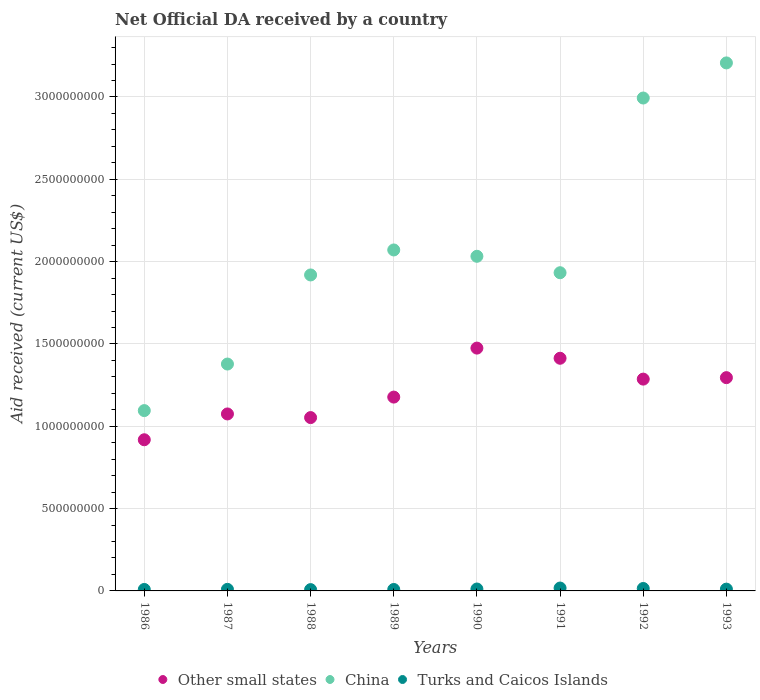What is the net official development assistance aid received in Other small states in 1986?
Your answer should be compact. 9.18e+08. Across all years, what is the maximum net official development assistance aid received in Other small states?
Provide a succinct answer. 1.47e+09. Across all years, what is the minimum net official development assistance aid received in Other small states?
Your answer should be compact. 9.18e+08. In which year was the net official development assistance aid received in Turks and Caicos Islands maximum?
Keep it short and to the point. 1991. In which year was the net official development assistance aid received in Turks and Caicos Islands minimum?
Offer a very short reply. 1988. What is the total net official development assistance aid received in Other small states in the graph?
Your answer should be very brief. 9.69e+09. What is the difference between the net official development assistance aid received in Turks and Caicos Islands in 1990 and that in 1992?
Keep it short and to the point. -3.20e+06. What is the difference between the net official development assistance aid received in China in 1991 and the net official development assistance aid received in Turks and Caicos Islands in 1992?
Provide a succinct answer. 1.92e+09. What is the average net official development assistance aid received in Other small states per year?
Your answer should be compact. 1.21e+09. In the year 1992, what is the difference between the net official development assistance aid received in China and net official development assistance aid received in Turks and Caicos Islands?
Your answer should be very brief. 2.98e+09. What is the ratio of the net official development assistance aid received in Turks and Caicos Islands in 1988 to that in 1989?
Your response must be concise. 0.9. Is the difference between the net official development assistance aid received in China in 1986 and 1987 greater than the difference between the net official development assistance aid received in Turks and Caicos Islands in 1986 and 1987?
Your answer should be very brief. No. What is the difference between the highest and the second highest net official development assistance aid received in China?
Your answer should be very brief. 2.13e+08. What is the difference between the highest and the lowest net official development assistance aid received in Other small states?
Your answer should be compact. 5.57e+08. Is it the case that in every year, the sum of the net official development assistance aid received in China and net official development assistance aid received in Other small states  is greater than the net official development assistance aid received in Turks and Caicos Islands?
Your answer should be very brief. Yes. Does the net official development assistance aid received in Turks and Caicos Islands monotonically increase over the years?
Your answer should be compact. No. Is the net official development assistance aid received in Other small states strictly greater than the net official development assistance aid received in China over the years?
Ensure brevity in your answer.  No. How many dotlines are there?
Offer a very short reply. 3. How many years are there in the graph?
Your answer should be compact. 8. What is the difference between two consecutive major ticks on the Y-axis?
Offer a terse response. 5.00e+08. Are the values on the major ticks of Y-axis written in scientific E-notation?
Offer a terse response. No. Does the graph contain grids?
Keep it short and to the point. Yes. What is the title of the graph?
Your answer should be very brief. Net Official DA received by a country. What is the label or title of the X-axis?
Keep it short and to the point. Years. What is the label or title of the Y-axis?
Keep it short and to the point. Aid received (current US$). What is the Aid received (current US$) of Other small states in 1986?
Provide a short and direct response. 9.18e+08. What is the Aid received (current US$) of China in 1986?
Offer a very short reply. 1.10e+09. What is the Aid received (current US$) in Turks and Caicos Islands in 1986?
Your response must be concise. 8.89e+06. What is the Aid received (current US$) of Other small states in 1987?
Offer a very short reply. 1.07e+09. What is the Aid received (current US$) of China in 1987?
Make the answer very short. 1.38e+09. What is the Aid received (current US$) in Turks and Caicos Islands in 1987?
Provide a succinct answer. 9.55e+06. What is the Aid received (current US$) in Other small states in 1988?
Give a very brief answer. 1.05e+09. What is the Aid received (current US$) in China in 1988?
Provide a short and direct response. 1.92e+09. What is the Aid received (current US$) in Turks and Caicos Islands in 1988?
Offer a very short reply. 7.89e+06. What is the Aid received (current US$) of Other small states in 1989?
Provide a short and direct response. 1.18e+09. What is the Aid received (current US$) in China in 1989?
Your answer should be very brief. 2.07e+09. What is the Aid received (current US$) of Turks and Caicos Islands in 1989?
Keep it short and to the point. 8.78e+06. What is the Aid received (current US$) of Other small states in 1990?
Offer a very short reply. 1.47e+09. What is the Aid received (current US$) of China in 1990?
Your response must be concise. 2.03e+09. What is the Aid received (current US$) of Turks and Caicos Islands in 1990?
Provide a succinct answer. 1.16e+07. What is the Aid received (current US$) of Other small states in 1991?
Provide a short and direct response. 1.41e+09. What is the Aid received (current US$) in China in 1991?
Your answer should be very brief. 1.93e+09. What is the Aid received (current US$) of Turks and Caicos Islands in 1991?
Offer a very short reply. 1.75e+07. What is the Aid received (current US$) in Other small states in 1992?
Keep it short and to the point. 1.29e+09. What is the Aid received (current US$) in China in 1992?
Your answer should be very brief. 2.99e+09. What is the Aid received (current US$) of Turks and Caicos Islands in 1992?
Ensure brevity in your answer.  1.48e+07. What is the Aid received (current US$) in Other small states in 1993?
Offer a very short reply. 1.30e+09. What is the Aid received (current US$) of China in 1993?
Your answer should be very brief. 3.21e+09. What is the Aid received (current US$) in Turks and Caicos Islands in 1993?
Your response must be concise. 1.09e+07. Across all years, what is the maximum Aid received (current US$) in Other small states?
Provide a succinct answer. 1.47e+09. Across all years, what is the maximum Aid received (current US$) of China?
Offer a very short reply. 3.21e+09. Across all years, what is the maximum Aid received (current US$) in Turks and Caicos Islands?
Provide a succinct answer. 1.75e+07. Across all years, what is the minimum Aid received (current US$) in Other small states?
Ensure brevity in your answer.  9.18e+08. Across all years, what is the minimum Aid received (current US$) in China?
Provide a short and direct response. 1.10e+09. Across all years, what is the minimum Aid received (current US$) of Turks and Caicos Islands?
Make the answer very short. 7.89e+06. What is the total Aid received (current US$) in Other small states in the graph?
Your answer should be very brief. 9.69e+09. What is the total Aid received (current US$) of China in the graph?
Your answer should be compact. 1.66e+1. What is the total Aid received (current US$) of Turks and Caicos Islands in the graph?
Provide a succinct answer. 8.99e+07. What is the difference between the Aid received (current US$) in Other small states in 1986 and that in 1987?
Keep it short and to the point. -1.57e+08. What is the difference between the Aid received (current US$) in China in 1986 and that in 1987?
Ensure brevity in your answer.  -2.83e+08. What is the difference between the Aid received (current US$) of Turks and Caicos Islands in 1986 and that in 1987?
Provide a succinct answer. -6.60e+05. What is the difference between the Aid received (current US$) in Other small states in 1986 and that in 1988?
Your response must be concise. -1.35e+08. What is the difference between the Aid received (current US$) in China in 1986 and that in 1988?
Offer a very short reply. -8.24e+08. What is the difference between the Aid received (current US$) of Turks and Caicos Islands in 1986 and that in 1988?
Keep it short and to the point. 1.00e+06. What is the difference between the Aid received (current US$) of Other small states in 1986 and that in 1989?
Your response must be concise. -2.59e+08. What is the difference between the Aid received (current US$) of China in 1986 and that in 1989?
Make the answer very short. -9.76e+08. What is the difference between the Aid received (current US$) of Turks and Caicos Islands in 1986 and that in 1989?
Offer a very short reply. 1.10e+05. What is the difference between the Aid received (current US$) in Other small states in 1986 and that in 1990?
Your answer should be compact. -5.57e+08. What is the difference between the Aid received (current US$) of China in 1986 and that in 1990?
Provide a short and direct response. -9.37e+08. What is the difference between the Aid received (current US$) of Turks and Caicos Islands in 1986 and that in 1990?
Give a very brief answer. -2.71e+06. What is the difference between the Aid received (current US$) of Other small states in 1986 and that in 1991?
Keep it short and to the point. -4.95e+08. What is the difference between the Aid received (current US$) of China in 1986 and that in 1991?
Ensure brevity in your answer.  -8.37e+08. What is the difference between the Aid received (current US$) of Turks and Caicos Islands in 1986 and that in 1991?
Your answer should be compact. -8.61e+06. What is the difference between the Aid received (current US$) of Other small states in 1986 and that in 1992?
Provide a short and direct response. -3.68e+08. What is the difference between the Aid received (current US$) in China in 1986 and that in 1992?
Give a very brief answer. -1.90e+09. What is the difference between the Aid received (current US$) of Turks and Caicos Islands in 1986 and that in 1992?
Make the answer very short. -5.91e+06. What is the difference between the Aid received (current US$) of Other small states in 1986 and that in 1993?
Your answer should be very brief. -3.77e+08. What is the difference between the Aid received (current US$) of China in 1986 and that in 1993?
Provide a succinct answer. -2.11e+09. What is the difference between the Aid received (current US$) in Turks and Caicos Islands in 1986 and that in 1993?
Your response must be concise. -2.01e+06. What is the difference between the Aid received (current US$) of Other small states in 1987 and that in 1988?
Make the answer very short. 2.21e+07. What is the difference between the Aid received (current US$) in China in 1987 and that in 1988?
Your answer should be very brief. -5.41e+08. What is the difference between the Aid received (current US$) of Turks and Caicos Islands in 1987 and that in 1988?
Your response must be concise. 1.66e+06. What is the difference between the Aid received (current US$) in Other small states in 1987 and that in 1989?
Offer a very short reply. -1.02e+08. What is the difference between the Aid received (current US$) of China in 1987 and that in 1989?
Offer a very short reply. -6.93e+08. What is the difference between the Aid received (current US$) in Turks and Caicos Islands in 1987 and that in 1989?
Provide a succinct answer. 7.70e+05. What is the difference between the Aid received (current US$) of Other small states in 1987 and that in 1990?
Provide a succinct answer. -4.00e+08. What is the difference between the Aid received (current US$) in China in 1987 and that in 1990?
Ensure brevity in your answer.  -6.54e+08. What is the difference between the Aid received (current US$) of Turks and Caicos Islands in 1987 and that in 1990?
Your answer should be very brief. -2.05e+06. What is the difference between the Aid received (current US$) in Other small states in 1987 and that in 1991?
Your answer should be compact. -3.38e+08. What is the difference between the Aid received (current US$) in China in 1987 and that in 1991?
Ensure brevity in your answer.  -5.55e+08. What is the difference between the Aid received (current US$) of Turks and Caicos Islands in 1987 and that in 1991?
Keep it short and to the point. -7.95e+06. What is the difference between the Aid received (current US$) in Other small states in 1987 and that in 1992?
Your response must be concise. -2.12e+08. What is the difference between the Aid received (current US$) of China in 1987 and that in 1992?
Provide a short and direct response. -1.62e+09. What is the difference between the Aid received (current US$) in Turks and Caicos Islands in 1987 and that in 1992?
Offer a terse response. -5.25e+06. What is the difference between the Aid received (current US$) of Other small states in 1987 and that in 1993?
Keep it short and to the point. -2.20e+08. What is the difference between the Aid received (current US$) of China in 1987 and that in 1993?
Make the answer very short. -1.83e+09. What is the difference between the Aid received (current US$) of Turks and Caicos Islands in 1987 and that in 1993?
Provide a succinct answer. -1.35e+06. What is the difference between the Aid received (current US$) of Other small states in 1988 and that in 1989?
Offer a very short reply. -1.24e+08. What is the difference between the Aid received (current US$) in China in 1988 and that in 1989?
Give a very brief answer. -1.52e+08. What is the difference between the Aid received (current US$) of Turks and Caicos Islands in 1988 and that in 1989?
Offer a very short reply. -8.90e+05. What is the difference between the Aid received (current US$) in Other small states in 1988 and that in 1990?
Give a very brief answer. -4.22e+08. What is the difference between the Aid received (current US$) in China in 1988 and that in 1990?
Provide a succinct answer. -1.13e+08. What is the difference between the Aid received (current US$) in Turks and Caicos Islands in 1988 and that in 1990?
Offer a terse response. -3.71e+06. What is the difference between the Aid received (current US$) of Other small states in 1988 and that in 1991?
Give a very brief answer. -3.60e+08. What is the difference between the Aid received (current US$) in China in 1988 and that in 1991?
Make the answer very short. -1.35e+07. What is the difference between the Aid received (current US$) in Turks and Caicos Islands in 1988 and that in 1991?
Make the answer very short. -9.61e+06. What is the difference between the Aid received (current US$) in Other small states in 1988 and that in 1992?
Provide a short and direct response. -2.34e+08. What is the difference between the Aid received (current US$) of China in 1988 and that in 1992?
Your answer should be compact. -1.07e+09. What is the difference between the Aid received (current US$) of Turks and Caicos Islands in 1988 and that in 1992?
Your response must be concise. -6.91e+06. What is the difference between the Aid received (current US$) of Other small states in 1988 and that in 1993?
Make the answer very short. -2.43e+08. What is the difference between the Aid received (current US$) in China in 1988 and that in 1993?
Your answer should be very brief. -1.29e+09. What is the difference between the Aid received (current US$) in Turks and Caicos Islands in 1988 and that in 1993?
Ensure brevity in your answer.  -3.01e+06. What is the difference between the Aid received (current US$) of Other small states in 1989 and that in 1990?
Offer a very short reply. -2.98e+08. What is the difference between the Aid received (current US$) of China in 1989 and that in 1990?
Ensure brevity in your answer.  3.85e+07. What is the difference between the Aid received (current US$) of Turks and Caicos Islands in 1989 and that in 1990?
Provide a short and direct response. -2.82e+06. What is the difference between the Aid received (current US$) of Other small states in 1989 and that in 1991?
Offer a terse response. -2.36e+08. What is the difference between the Aid received (current US$) of China in 1989 and that in 1991?
Your answer should be very brief. 1.38e+08. What is the difference between the Aid received (current US$) in Turks and Caicos Islands in 1989 and that in 1991?
Your answer should be very brief. -8.72e+06. What is the difference between the Aid received (current US$) in Other small states in 1989 and that in 1992?
Your response must be concise. -1.09e+08. What is the difference between the Aid received (current US$) in China in 1989 and that in 1992?
Give a very brief answer. -9.23e+08. What is the difference between the Aid received (current US$) of Turks and Caicos Islands in 1989 and that in 1992?
Offer a terse response. -6.02e+06. What is the difference between the Aid received (current US$) in Other small states in 1989 and that in 1993?
Provide a short and direct response. -1.18e+08. What is the difference between the Aid received (current US$) in China in 1989 and that in 1993?
Your response must be concise. -1.14e+09. What is the difference between the Aid received (current US$) of Turks and Caicos Islands in 1989 and that in 1993?
Offer a very short reply. -2.12e+06. What is the difference between the Aid received (current US$) of Other small states in 1990 and that in 1991?
Your answer should be very brief. 6.17e+07. What is the difference between the Aid received (current US$) of China in 1990 and that in 1991?
Offer a very short reply. 9.98e+07. What is the difference between the Aid received (current US$) in Turks and Caicos Islands in 1990 and that in 1991?
Offer a very short reply. -5.90e+06. What is the difference between the Aid received (current US$) in Other small states in 1990 and that in 1992?
Offer a terse response. 1.88e+08. What is the difference between the Aid received (current US$) in China in 1990 and that in 1992?
Offer a terse response. -9.61e+08. What is the difference between the Aid received (current US$) of Turks and Caicos Islands in 1990 and that in 1992?
Make the answer very short. -3.20e+06. What is the difference between the Aid received (current US$) in Other small states in 1990 and that in 1993?
Ensure brevity in your answer.  1.79e+08. What is the difference between the Aid received (current US$) in China in 1990 and that in 1993?
Provide a succinct answer. -1.17e+09. What is the difference between the Aid received (current US$) of Turks and Caicos Islands in 1990 and that in 1993?
Provide a short and direct response. 7.00e+05. What is the difference between the Aid received (current US$) in Other small states in 1991 and that in 1992?
Provide a short and direct response. 1.27e+08. What is the difference between the Aid received (current US$) of China in 1991 and that in 1992?
Offer a terse response. -1.06e+09. What is the difference between the Aid received (current US$) in Turks and Caicos Islands in 1991 and that in 1992?
Your response must be concise. 2.70e+06. What is the difference between the Aid received (current US$) in Other small states in 1991 and that in 1993?
Offer a terse response. 1.18e+08. What is the difference between the Aid received (current US$) of China in 1991 and that in 1993?
Provide a short and direct response. -1.27e+09. What is the difference between the Aid received (current US$) of Turks and Caicos Islands in 1991 and that in 1993?
Give a very brief answer. 6.60e+06. What is the difference between the Aid received (current US$) in Other small states in 1992 and that in 1993?
Your answer should be very brief. -8.92e+06. What is the difference between the Aid received (current US$) of China in 1992 and that in 1993?
Ensure brevity in your answer.  -2.13e+08. What is the difference between the Aid received (current US$) of Turks and Caicos Islands in 1992 and that in 1993?
Give a very brief answer. 3.90e+06. What is the difference between the Aid received (current US$) in Other small states in 1986 and the Aid received (current US$) in China in 1987?
Keep it short and to the point. -4.60e+08. What is the difference between the Aid received (current US$) of Other small states in 1986 and the Aid received (current US$) of Turks and Caicos Islands in 1987?
Make the answer very short. 9.09e+08. What is the difference between the Aid received (current US$) in China in 1986 and the Aid received (current US$) in Turks and Caicos Islands in 1987?
Provide a short and direct response. 1.09e+09. What is the difference between the Aid received (current US$) in Other small states in 1986 and the Aid received (current US$) in China in 1988?
Ensure brevity in your answer.  -1.00e+09. What is the difference between the Aid received (current US$) of Other small states in 1986 and the Aid received (current US$) of Turks and Caicos Islands in 1988?
Offer a terse response. 9.10e+08. What is the difference between the Aid received (current US$) of China in 1986 and the Aid received (current US$) of Turks and Caicos Islands in 1988?
Provide a succinct answer. 1.09e+09. What is the difference between the Aid received (current US$) of Other small states in 1986 and the Aid received (current US$) of China in 1989?
Give a very brief answer. -1.15e+09. What is the difference between the Aid received (current US$) of Other small states in 1986 and the Aid received (current US$) of Turks and Caicos Islands in 1989?
Make the answer very short. 9.09e+08. What is the difference between the Aid received (current US$) in China in 1986 and the Aid received (current US$) in Turks and Caicos Islands in 1989?
Your answer should be very brief. 1.09e+09. What is the difference between the Aid received (current US$) in Other small states in 1986 and the Aid received (current US$) in China in 1990?
Your response must be concise. -1.11e+09. What is the difference between the Aid received (current US$) in Other small states in 1986 and the Aid received (current US$) in Turks and Caicos Islands in 1990?
Give a very brief answer. 9.06e+08. What is the difference between the Aid received (current US$) in China in 1986 and the Aid received (current US$) in Turks and Caicos Islands in 1990?
Offer a very short reply. 1.08e+09. What is the difference between the Aid received (current US$) in Other small states in 1986 and the Aid received (current US$) in China in 1991?
Offer a terse response. -1.01e+09. What is the difference between the Aid received (current US$) in Other small states in 1986 and the Aid received (current US$) in Turks and Caicos Islands in 1991?
Your response must be concise. 9.01e+08. What is the difference between the Aid received (current US$) in China in 1986 and the Aid received (current US$) in Turks and Caicos Islands in 1991?
Keep it short and to the point. 1.08e+09. What is the difference between the Aid received (current US$) of Other small states in 1986 and the Aid received (current US$) of China in 1992?
Keep it short and to the point. -2.08e+09. What is the difference between the Aid received (current US$) in Other small states in 1986 and the Aid received (current US$) in Turks and Caicos Islands in 1992?
Give a very brief answer. 9.03e+08. What is the difference between the Aid received (current US$) of China in 1986 and the Aid received (current US$) of Turks and Caicos Islands in 1992?
Give a very brief answer. 1.08e+09. What is the difference between the Aid received (current US$) of Other small states in 1986 and the Aid received (current US$) of China in 1993?
Provide a succinct answer. -2.29e+09. What is the difference between the Aid received (current US$) in Other small states in 1986 and the Aid received (current US$) in Turks and Caicos Islands in 1993?
Your response must be concise. 9.07e+08. What is the difference between the Aid received (current US$) of China in 1986 and the Aid received (current US$) of Turks and Caicos Islands in 1993?
Provide a short and direct response. 1.08e+09. What is the difference between the Aid received (current US$) of Other small states in 1987 and the Aid received (current US$) of China in 1988?
Provide a short and direct response. -8.44e+08. What is the difference between the Aid received (current US$) in Other small states in 1987 and the Aid received (current US$) in Turks and Caicos Islands in 1988?
Provide a succinct answer. 1.07e+09. What is the difference between the Aid received (current US$) in China in 1987 and the Aid received (current US$) in Turks and Caicos Islands in 1988?
Your answer should be compact. 1.37e+09. What is the difference between the Aid received (current US$) in Other small states in 1987 and the Aid received (current US$) in China in 1989?
Your response must be concise. -9.96e+08. What is the difference between the Aid received (current US$) in Other small states in 1987 and the Aid received (current US$) in Turks and Caicos Islands in 1989?
Your answer should be compact. 1.07e+09. What is the difference between the Aid received (current US$) in China in 1987 and the Aid received (current US$) in Turks and Caicos Islands in 1989?
Your answer should be very brief. 1.37e+09. What is the difference between the Aid received (current US$) in Other small states in 1987 and the Aid received (current US$) in China in 1990?
Offer a terse response. -9.58e+08. What is the difference between the Aid received (current US$) in Other small states in 1987 and the Aid received (current US$) in Turks and Caicos Islands in 1990?
Provide a short and direct response. 1.06e+09. What is the difference between the Aid received (current US$) of China in 1987 and the Aid received (current US$) of Turks and Caicos Islands in 1990?
Provide a short and direct response. 1.37e+09. What is the difference between the Aid received (current US$) in Other small states in 1987 and the Aid received (current US$) in China in 1991?
Keep it short and to the point. -8.58e+08. What is the difference between the Aid received (current US$) in Other small states in 1987 and the Aid received (current US$) in Turks and Caicos Islands in 1991?
Offer a terse response. 1.06e+09. What is the difference between the Aid received (current US$) in China in 1987 and the Aid received (current US$) in Turks and Caicos Islands in 1991?
Offer a terse response. 1.36e+09. What is the difference between the Aid received (current US$) of Other small states in 1987 and the Aid received (current US$) of China in 1992?
Provide a short and direct response. -1.92e+09. What is the difference between the Aid received (current US$) of Other small states in 1987 and the Aid received (current US$) of Turks and Caicos Islands in 1992?
Your answer should be compact. 1.06e+09. What is the difference between the Aid received (current US$) in China in 1987 and the Aid received (current US$) in Turks and Caicos Islands in 1992?
Offer a very short reply. 1.36e+09. What is the difference between the Aid received (current US$) of Other small states in 1987 and the Aid received (current US$) of China in 1993?
Your answer should be very brief. -2.13e+09. What is the difference between the Aid received (current US$) of Other small states in 1987 and the Aid received (current US$) of Turks and Caicos Islands in 1993?
Give a very brief answer. 1.06e+09. What is the difference between the Aid received (current US$) in China in 1987 and the Aid received (current US$) in Turks and Caicos Islands in 1993?
Your answer should be compact. 1.37e+09. What is the difference between the Aid received (current US$) in Other small states in 1988 and the Aid received (current US$) in China in 1989?
Your answer should be very brief. -1.02e+09. What is the difference between the Aid received (current US$) of Other small states in 1988 and the Aid received (current US$) of Turks and Caicos Islands in 1989?
Your response must be concise. 1.04e+09. What is the difference between the Aid received (current US$) in China in 1988 and the Aid received (current US$) in Turks and Caicos Islands in 1989?
Make the answer very short. 1.91e+09. What is the difference between the Aid received (current US$) in Other small states in 1988 and the Aid received (current US$) in China in 1990?
Your answer should be compact. -9.80e+08. What is the difference between the Aid received (current US$) in Other small states in 1988 and the Aid received (current US$) in Turks and Caicos Islands in 1990?
Offer a terse response. 1.04e+09. What is the difference between the Aid received (current US$) of China in 1988 and the Aid received (current US$) of Turks and Caicos Islands in 1990?
Make the answer very short. 1.91e+09. What is the difference between the Aid received (current US$) of Other small states in 1988 and the Aid received (current US$) of China in 1991?
Make the answer very short. -8.80e+08. What is the difference between the Aid received (current US$) in Other small states in 1988 and the Aid received (current US$) in Turks and Caicos Islands in 1991?
Your answer should be very brief. 1.04e+09. What is the difference between the Aid received (current US$) in China in 1988 and the Aid received (current US$) in Turks and Caicos Islands in 1991?
Provide a short and direct response. 1.90e+09. What is the difference between the Aid received (current US$) of Other small states in 1988 and the Aid received (current US$) of China in 1992?
Ensure brevity in your answer.  -1.94e+09. What is the difference between the Aid received (current US$) in Other small states in 1988 and the Aid received (current US$) in Turks and Caicos Islands in 1992?
Ensure brevity in your answer.  1.04e+09. What is the difference between the Aid received (current US$) of China in 1988 and the Aid received (current US$) of Turks and Caicos Islands in 1992?
Make the answer very short. 1.90e+09. What is the difference between the Aid received (current US$) in Other small states in 1988 and the Aid received (current US$) in China in 1993?
Ensure brevity in your answer.  -2.15e+09. What is the difference between the Aid received (current US$) of Other small states in 1988 and the Aid received (current US$) of Turks and Caicos Islands in 1993?
Ensure brevity in your answer.  1.04e+09. What is the difference between the Aid received (current US$) in China in 1988 and the Aid received (current US$) in Turks and Caicos Islands in 1993?
Make the answer very short. 1.91e+09. What is the difference between the Aid received (current US$) in Other small states in 1989 and the Aid received (current US$) in China in 1990?
Give a very brief answer. -8.55e+08. What is the difference between the Aid received (current US$) of Other small states in 1989 and the Aid received (current US$) of Turks and Caicos Islands in 1990?
Provide a short and direct response. 1.17e+09. What is the difference between the Aid received (current US$) in China in 1989 and the Aid received (current US$) in Turks and Caicos Islands in 1990?
Make the answer very short. 2.06e+09. What is the difference between the Aid received (current US$) of Other small states in 1989 and the Aid received (current US$) of China in 1991?
Offer a terse response. -7.55e+08. What is the difference between the Aid received (current US$) of Other small states in 1989 and the Aid received (current US$) of Turks and Caicos Islands in 1991?
Make the answer very short. 1.16e+09. What is the difference between the Aid received (current US$) in China in 1989 and the Aid received (current US$) in Turks and Caicos Islands in 1991?
Ensure brevity in your answer.  2.05e+09. What is the difference between the Aid received (current US$) of Other small states in 1989 and the Aid received (current US$) of China in 1992?
Provide a succinct answer. -1.82e+09. What is the difference between the Aid received (current US$) of Other small states in 1989 and the Aid received (current US$) of Turks and Caicos Islands in 1992?
Your answer should be very brief. 1.16e+09. What is the difference between the Aid received (current US$) of China in 1989 and the Aid received (current US$) of Turks and Caicos Islands in 1992?
Ensure brevity in your answer.  2.06e+09. What is the difference between the Aid received (current US$) in Other small states in 1989 and the Aid received (current US$) in China in 1993?
Ensure brevity in your answer.  -2.03e+09. What is the difference between the Aid received (current US$) of Other small states in 1989 and the Aid received (current US$) of Turks and Caicos Islands in 1993?
Make the answer very short. 1.17e+09. What is the difference between the Aid received (current US$) in China in 1989 and the Aid received (current US$) in Turks and Caicos Islands in 1993?
Give a very brief answer. 2.06e+09. What is the difference between the Aid received (current US$) of Other small states in 1990 and the Aid received (current US$) of China in 1991?
Your response must be concise. -4.58e+08. What is the difference between the Aid received (current US$) in Other small states in 1990 and the Aid received (current US$) in Turks and Caicos Islands in 1991?
Ensure brevity in your answer.  1.46e+09. What is the difference between the Aid received (current US$) of China in 1990 and the Aid received (current US$) of Turks and Caicos Islands in 1991?
Your answer should be very brief. 2.01e+09. What is the difference between the Aid received (current US$) of Other small states in 1990 and the Aid received (current US$) of China in 1992?
Offer a terse response. -1.52e+09. What is the difference between the Aid received (current US$) of Other small states in 1990 and the Aid received (current US$) of Turks and Caicos Islands in 1992?
Ensure brevity in your answer.  1.46e+09. What is the difference between the Aid received (current US$) in China in 1990 and the Aid received (current US$) in Turks and Caicos Islands in 1992?
Ensure brevity in your answer.  2.02e+09. What is the difference between the Aid received (current US$) of Other small states in 1990 and the Aid received (current US$) of China in 1993?
Provide a succinct answer. -1.73e+09. What is the difference between the Aid received (current US$) in Other small states in 1990 and the Aid received (current US$) in Turks and Caicos Islands in 1993?
Provide a short and direct response. 1.46e+09. What is the difference between the Aid received (current US$) of China in 1990 and the Aid received (current US$) of Turks and Caicos Islands in 1993?
Give a very brief answer. 2.02e+09. What is the difference between the Aid received (current US$) in Other small states in 1991 and the Aid received (current US$) in China in 1992?
Make the answer very short. -1.58e+09. What is the difference between the Aid received (current US$) in Other small states in 1991 and the Aid received (current US$) in Turks and Caicos Islands in 1992?
Ensure brevity in your answer.  1.40e+09. What is the difference between the Aid received (current US$) in China in 1991 and the Aid received (current US$) in Turks and Caicos Islands in 1992?
Your response must be concise. 1.92e+09. What is the difference between the Aid received (current US$) of Other small states in 1991 and the Aid received (current US$) of China in 1993?
Offer a very short reply. -1.79e+09. What is the difference between the Aid received (current US$) of Other small states in 1991 and the Aid received (current US$) of Turks and Caicos Islands in 1993?
Offer a terse response. 1.40e+09. What is the difference between the Aid received (current US$) of China in 1991 and the Aid received (current US$) of Turks and Caicos Islands in 1993?
Your response must be concise. 1.92e+09. What is the difference between the Aid received (current US$) in Other small states in 1992 and the Aid received (current US$) in China in 1993?
Make the answer very short. -1.92e+09. What is the difference between the Aid received (current US$) in Other small states in 1992 and the Aid received (current US$) in Turks and Caicos Islands in 1993?
Make the answer very short. 1.28e+09. What is the difference between the Aid received (current US$) of China in 1992 and the Aid received (current US$) of Turks and Caicos Islands in 1993?
Your answer should be compact. 2.98e+09. What is the average Aid received (current US$) of Other small states per year?
Keep it short and to the point. 1.21e+09. What is the average Aid received (current US$) in China per year?
Your answer should be very brief. 2.08e+09. What is the average Aid received (current US$) in Turks and Caicos Islands per year?
Provide a short and direct response. 1.12e+07. In the year 1986, what is the difference between the Aid received (current US$) in Other small states and Aid received (current US$) in China?
Your response must be concise. -1.77e+08. In the year 1986, what is the difference between the Aid received (current US$) in Other small states and Aid received (current US$) in Turks and Caicos Islands?
Your response must be concise. 9.09e+08. In the year 1986, what is the difference between the Aid received (current US$) in China and Aid received (current US$) in Turks and Caicos Islands?
Offer a very short reply. 1.09e+09. In the year 1987, what is the difference between the Aid received (current US$) in Other small states and Aid received (current US$) in China?
Provide a succinct answer. -3.03e+08. In the year 1987, what is the difference between the Aid received (current US$) of Other small states and Aid received (current US$) of Turks and Caicos Islands?
Keep it short and to the point. 1.07e+09. In the year 1987, what is the difference between the Aid received (current US$) of China and Aid received (current US$) of Turks and Caicos Islands?
Your answer should be very brief. 1.37e+09. In the year 1988, what is the difference between the Aid received (current US$) in Other small states and Aid received (current US$) in China?
Keep it short and to the point. -8.66e+08. In the year 1988, what is the difference between the Aid received (current US$) of Other small states and Aid received (current US$) of Turks and Caicos Islands?
Offer a terse response. 1.04e+09. In the year 1988, what is the difference between the Aid received (current US$) of China and Aid received (current US$) of Turks and Caicos Islands?
Ensure brevity in your answer.  1.91e+09. In the year 1989, what is the difference between the Aid received (current US$) of Other small states and Aid received (current US$) of China?
Offer a very short reply. -8.94e+08. In the year 1989, what is the difference between the Aid received (current US$) of Other small states and Aid received (current US$) of Turks and Caicos Islands?
Provide a succinct answer. 1.17e+09. In the year 1989, what is the difference between the Aid received (current US$) of China and Aid received (current US$) of Turks and Caicos Islands?
Offer a very short reply. 2.06e+09. In the year 1990, what is the difference between the Aid received (current US$) of Other small states and Aid received (current US$) of China?
Your response must be concise. -5.58e+08. In the year 1990, what is the difference between the Aid received (current US$) of Other small states and Aid received (current US$) of Turks and Caicos Islands?
Keep it short and to the point. 1.46e+09. In the year 1990, what is the difference between the Aid received (current US$) in China and Aid received (current US$) in Turks and Caicos Islands?
Ensure brevity in your answer.  2.02e+09. In the year 1991, what is the difference between the Aid received (current US$) in Other small states and Aid received (current US$) in China?
Ensure brevity in your answer.  -5.20e+08. In the year 1991, what is the difference between the Aid received (current US$) of Other small states and Aid received (current US$) of Turks and Caicos Islands?
Make the answer very short. 1.40e+09. In the year 1991, what is the difference between the Aid received (current US$) of China and Aid received (current US$) of Turks and Caicos Islands?
Make the answer very short. 1.92e+09. In the year 1992, what is the difference between the Aid received (current US$) in Other small states and Aid received (current US$) in China?
Offer a terse response. -1.71e+09. In the year 1992, what is the difference between the Aid received (current US$) of Other small states and Aid received (current US$) of Turks and Caicos Islands?
Make the answer very short. 1.27e+09. In the year 1992, what is the difference between the Aid received (current US$) of China and Aid received (current US$) of Turks and Caicos Islands?
Provide a short and direct response. 2.98e+09. In the year 1993, what is the difference between the Aid received (current US$) of Other small states and Aid received (current US$) of China?
Provide a short and direct response. -1.91e+09. In the year 1993, what is the difference between the Aid received (current US$) in Other small states and Aid received (current US$) in Turks and Caicos Islands?
Your answer should be very brief. 1.28e+09. In the year 1993, what is the difference between the Aid received (current US$) in China and Aid received (current US$) in Turks and Caicos Islands?
Your answer should be compact. 3.20e+09. What is the ratio of the Aid received (current US$) of Other small states in 1986 to that in 1987?
Provide a succinct answer. 0.85. What is the ratio of the Aid received (current US$) of China in 1986 to that in 1987?
Your answer should be compact. 0.79. What is the ratio of the Aid received (current US$) of Turks and Caicos Islands in 1986 to that in 1987?
Your answer should be very brief. 0.93. What is the ratio of the Aid received (current US$) of Other small states in 1986 to that in 1988?
Make the answer very short. 0.87. What is the ratio of the Aid received (current US$) in China in 1986 to that in 1988?
Give a very brief answer. 0.57. What is the ratio of the Aid received (current US$) of Turks and Caicos Islands in 1986 to that in 1988?
Offer a very short reply. 1.13. What is the ratio of the Aid received (current US$) in Other small states in 1986 to that in 1989?
Ensure brevity in your answer.  0.78. What is the ratio of the Aid received (current US$) of China in 1986 to that in 1989?
Your response must be concise. 0.53. What is the ratio of the Aid received (current US$) of Turks and Caicos Islands in 1986 to that in 1989?
Keep it short and to the point. 1.01. What is the ratio of the Aid received (current US$) in Other small states in 1986 to that in 1990?
Ensure brevity in your answer.  0.62. What is the ratio of the Aid received (current US$) of China in 1986 to that in 1990?
Provide a succinct answer. 0.54. What is the ratio of the Aid received (current US$) of Turks and Caicos Islands in 1986 to that in 1990?
Your answer should be compact. 0.77. What is the ratio of the Aid received (current US$) in Other small states in 1986 to that in 1991?
Your answer should be very brief. 0.65. What is the ratio of the Aid received (current US$) in China in 1986 to that in 1991?
Keep it short and to the point. 0.57. What is the ratio of the Aid received (current US$) of Turks and Caicos Islands in 1986 to that in 1991?
Your answer should be very brief. 0.51. What is the ratio of the Aid received (current US$) in Other small states in 1986 to that in 1992?
Ensure brevity in your answer.  0.71. What is the ratio of the Aid received (current US$) of China in 1986 to that in 1992?
Offer a terse response. 0.37. What is the ratio of the Aid received (current US$) in Turks and Caicos Islands in 1986 to that in 1992?
Offer a terse response. 0.6. What is the ratio of the Aid received (current US$) of Other small states in 1986 to that in 1993?
Your answer should be compact. 0.71. What is the ratio of the Aid received (current US$) of China in 1986 to that in 1993?
Keep it short and to the point. 0.34. What is the ratio of the Aid received (current US$) of Turks and Caicos Islands in 1986 to that in 1993?
Your answer should be compact. 0.82. What is the ratio of the Aid received (current US$) in Other small states in 1987 to that in 1988?
Keep it short and to the point. 1.02. What is the ratio of the Aid received (current US$) in China in 1987 to that in 1988?
Provide a short and direct response. 0.72. What is the ratio of the Aid received (current US$) in Turks and Caicos Islands in 1987 to that in 1988?
Keep it short and to the point. 1.21. What is the ratio of the Aid received (current US$) in Other small states in 1987 to that in 1989?
Your answer should be very brief. 0.91. What is the ratio of the Aid received (current US$) in China in 1987 to that in 1989?
Your response must be concise. 0.67. What is the ratio of the Aid received (current US$) of Turks and Caicos Islands in 1987 to that in 1989?
Provide a succinct answer. 1.09. What is the ratio of the Aid received (current US$) in Other small states in 1987 to that in 1990?
Ensure brevity in your answer.  0.73. What is the ratio of the Aid received (current US$) in China in 1987 to that in 1990?
Ensure brevity in your answer.  0.68. What is the ratio of the Aid received (current US$) of Turks and Caicos Islands in 1987 to that in 1990?
Your answer should be very brief. 0.82. What is the ratio of the Aid received (current US$) of Other small states in 1987 to that in 1991?
Keep it short and to the point. 0.76. What is the ratio of the Aid received (current US$) of China in 1987 to that in 1991?
Your answer should be compact. 0.71. What is the ratio of the Aid received (current US$) of Turks and Caicos Islands in 1987 to that in 1991?
Provide a succinct answer. 0.55. What is the ratio of the Aid received (current US$) of Other small states in 1987 to that in 1992?
Provide a succinct answer. 0.84. What is the ratio of the Aid received (current US$) of China in 1987 to that in 1992?
Your answer should be very brief. 0.46. What is the ratio of the Aid received (current US$) in Turks and Caicos Islands in 1987 to that in 1992?
Provide a short and direct response. 0.65. What is the ratio of the Aid received (current US$) of Other small states in 1987 to that in 1993?
Offer a very short reply. 0.83. What is the ratio of the Aid received (current US$) of China in 1987 to that in 1993?
Keep it short and to the point. 0.43. What is the ratio of the Aid received (current US$) in Turks and Caicos Islands in 1987 to that in 1993?
Your answer should be compact. 0.88. What is the ratio of the Aid received (current US$) of Other small states in 1988 to that in 1989?
Offer a terse response. 0.89. What is the ratio of the Aid received (current US$) of China in 1988 to that in 1989?
Make the answer very short. 0.93. What is the ratio of the Aid received (current US$) in Turks and Caicos Islands in 1988 to that in 1989?
Ensure brevity in your answer.  0.9. What is the ratio of the Aid received (current US$) of Other small states in 1988 to that in 1990?
Provide a succinct answer. 0.71. What is the ratio of the Aid received (current US$) in China in 1988 to that in 1990?
Provide a short and direct response. 0.94. What is the ratio of the Aid received (current US$) in Turks and Caicos Islands in 1988 to that in 1990?
Keep it short and to the point. 0.68. What is the ratio of the Aid received (current US$) in Other small states in 1988 to that in 1991?
Offer a very short reply. 0.74. What is the ratio of the Aid received (current US$) in Turks and Caicos Islands in 1988 to that in 1991?
Offer a very short reply. 0.45. What is the ratio of the Aid received (current US$) of Other small states in 1988 to that in 1992?
Keep it short and to the point. 0.82. What is the ratio of the Aid received (current US$) in China in 1988 to that in 1992?
Provide a succinct answer. 0.64. What is the ratio of the Aid received (current US$) of Turks and Caicos Islands in 1988 to that in 1992?
Your answer should be very brief. 0.53. What is the ratio of the Aid received (current US$) of Other small states in 1988 to that in 1993?
Your answer should be very brief. 0.81. What is the ratio of the Aid received (current US$) in China in 1988 to that in 1993?
Give a very brief answer. 0.6. What is the ratio of the Aid received (current US$) in Turks and Caicos Islands in 1988 to that in 1993?
Your response must be concise. 0.72. What is the ratio of the Aid received (current US$) in Other small states in 1989 to that in 1990?
Your answer should be compact. 0.8. What is the ratio of the Aid received (current US$) of China in 1989 to that in 1990?
Provide a succinct answer. 1.02. What is the ratio of the Aid received (current US$) of Turks and Caicos Islands in 1989 to that in 1990?
Provide a short and direct response. 0.76. What is the ratio of the Aid received (current US$) in Other small states in 1989 to that in 1991?
Make the answer very short. 0.83. What is the ratio of the Aid received (current US$) in China in 1989 to that in 1991?
Make the answer very short. 1.07. What is the ratio of the Aid received (current US$) of Turks and Caicos Islands in 1989 to that in 1991?
Offer a very short reply. 0.5. What is the ratio of the Aid received (current US$) of Other small states in 1989 to that in 1992?
Your response must be concise. 0.92. What is the ratio of the Aid received (current US$) in China in 1989 to that in 1992?
Give a very brief answer. 0.69. What is the ratio of the Aid received (current US$) in Turks and Caicos Islands in 1989 to that in 1992?
Provide a succinct answer. 0.59. What is the ratio of the Aid received (current US$) in Other small states in 1989 to that in 1993?
Your response must be concise. 0.91. What is the ratio of the Aid received (current US$) of China in 1989 to that in 1993?
Keep it short and to the point. 0.65. What is the ratio of the Aid received (current US$) in Turks and Caicos Islands in 1989 to that in 1993?
Make the answer very short. 0.81. What is the ratio of the Aid received (current US$) of Other small states in 1990 to that in 1991?
Offer a very short reply. 1.04. What is the ratio of the Aid received (current US$) of China in 1990 to that in 1991?
Give a very brief answer. 1.05. What is the ratio of the Aid received (current US$) of Turks and Caicos Islands in 1990 to that in 1991?
Keep it short and to the point. 0.66. What is the ratio of the Aid received (current US$) of Other small states in 1990 to that in 1992?
Provide a succinct answer. 1.15. What is the ratio of the Aid received (current US$) of China in 1990 to that in 1992?
Keep it short and to the point. 0.68. What is the ratio of the Aid received (current US$) in Turks and Caicos Islands in 1990 to that in 1992?
Your response must be concise. 0.78. What is the ratio of the Aid received (current US$) of Other small states in 1990 to that in 1993?
Provide a short and direct response. 1.14. What is the ratio of the Aid received (current US$) of China in 1990 to that in 1993?
Give a very brief answer. 0.63. What is the ratio of the Aid received (current US$) in Turks and Caicos Islands in 1990 to that in 1993?
Give a very brief answer. 1.06. What is the ratio of the Aid received (current US$) in Other small states in 1991 to that in 1992?
Give a very brief answer. 1.1. What is the ratio of the Aid received (current US$) in China in 1991 to that in 1992?
Offer a very short reply. 0.65. What is the ratio of the Aid received (current US$) of Turks and Caicos Islands in 1991 to that in 1992?
Keep it short and to the point. 1.18. What is the ratio of the Aid received (current US$) in Other small states in 1991 to that in 1993?
Your response must be concise. 1.09. What is the ratio of the Aid received (current US$) in China in 1991 to that in 1993?
Offer a terse response. 0.6. What is the ratio of the Aid received (current US$) of Turks and Caicos Islands in 1991 to that in 1993?
Make the answer very short. 1.61. What is the ratio of the Aid received (current US$) in China in 1992 to that in 1993?
Give a very brief answer. 0.93. What is the ratio of the Aid received (current US$) in Turks and Caicos Islands in 1992 to that in 1993?
Offer a very short reply. 1.36. What is the difference between the highest and the second highest Aid received (current US$) in Other small states?
Your answer should be compact. 6.17e+07. What is the difference between the highest and the second highest Aid received (current US$) of China?
Ensure brevity in your answer.  2.13e+08. What is the difference between the highest and the second highest Aid received (current US$) of Turks and Caicos Islands?
Keep it short and to the point. 2.70e+06. What is the difference between the highest and the lowest Aid received (current US$) of Other small states?
Keep it short and to the point. 5.57e+08. What is the difference between the highest and the lowest Aid received (current US$) in China?
Ensure brevity in your answer.  2.11e+09. What is the difference between the highest and the lowest Aid received (current US$) of Turks and Caicos Islands?
Your answer should be very brief. 9.61e+06. 